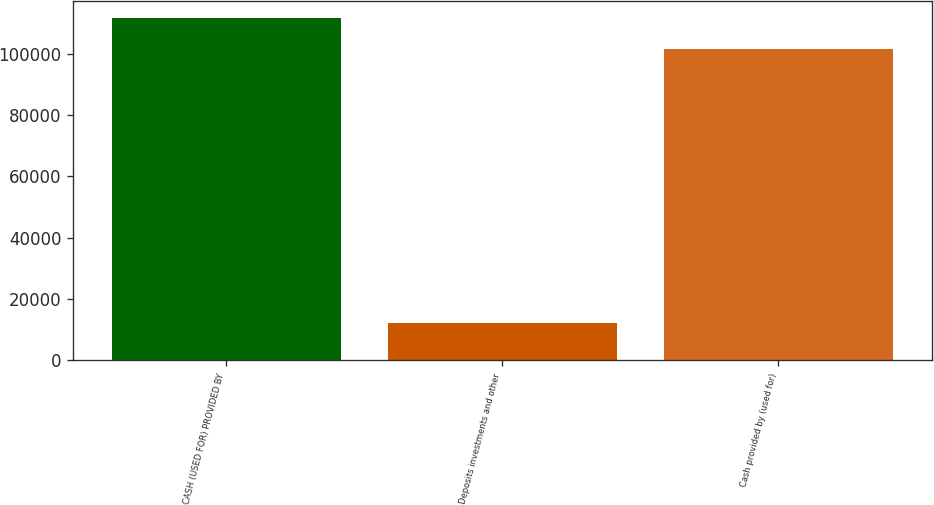Convert chart to OTSL. <chart><loc_0><loc_0><loc_500><loc_500><bar_chart><fcel>CASH (USED FOR) PROVIDED BY<fcel>Deposits investments and other<fcel>Cash provided by (used for)<nl><fcel>111743<fcel>12248<fcel>101442<nl></chart> 